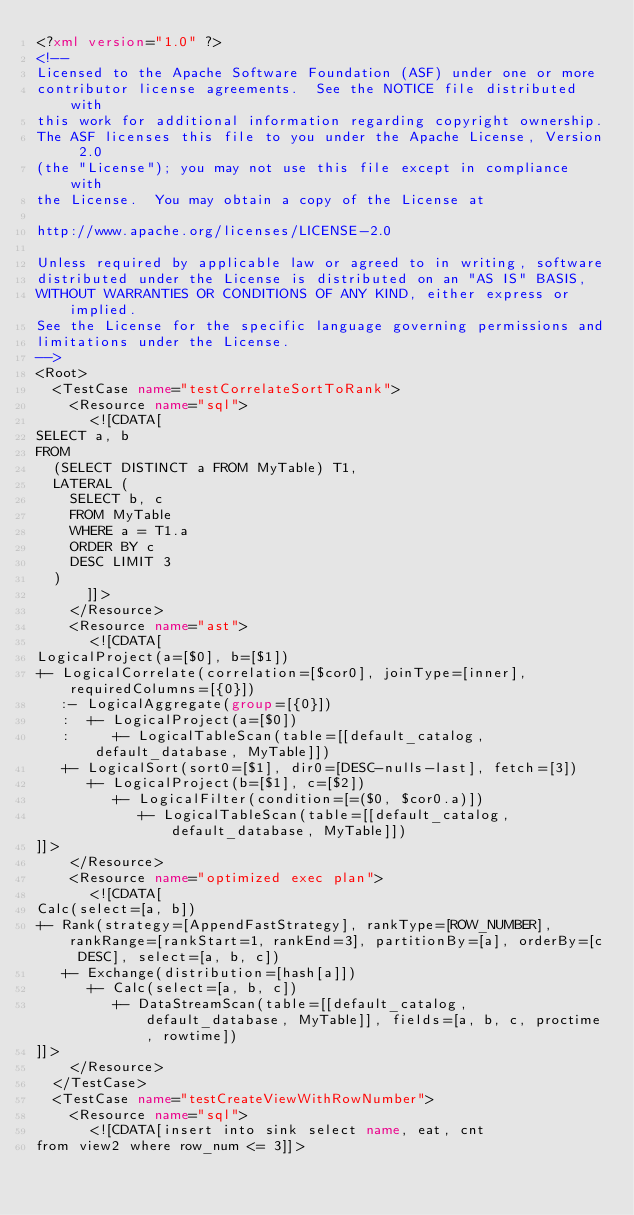Convert code to text. <code><loc_0><loc_0><loc_500><loc_500><_XML_><?xml version="1.0" ?>
<!--
Licensed to the Apache Software Foundation (ASF) under one or more
contributor license agreements.  See the NOTICE file distributed with
this work for additional information regarding copyright ownership.
The ASF licenses this file to you under the Apache License, Version 2.0
(the "License"); you may not use this file except in compliance with
the License.  You may obtain a copy of the License at

http://www.apache.org/licenses/LICENSE-2.0

Unless required by applicable law or agreed to in writing, software
distributed under the License is distributed on an "AS IS" BASIS,
WITHOUT WARRANTIES OR CONDITIONS OF ANY KIND, either express or implied.
See the License for the specific language governing permissions and
limitations under the License.
-->
<Root>
  <TestCase name="testCorrelateSortToRank">
    <Resource name="sql">
      <![CDATA[
SELECT a, b
FROM
  (SELECT DISTINCT a FROM MyTable) T1,
  LATERAL (
    SELECT b, c
    FROM MyTable
    WHERE a = T1.a
    ORDER BY c
    DESC LIMIT 3
  )
      ]]>
    </Resource>
    <Resource name="ast">
      <![CDATA[
LogicalProject(a=[$0], b=[$1])
+- LogicalCorrelate(correlation=[$cor0], joinType=[inner], requiredColumns=[{0}])
   :- LogicalAggregate(group=[{0}])
   :  +- LogicalProject(a=[$0])
   :     +- LogicalTableScan(table=[[default_catalog, default_database, MyTable]])
   +- LogicalSort(sort0=[$1], dir0=[DESC-nulls-last], fetch=[3])
      +- LogicalProject(b=[$1], c=[$2])
         +- LogicalFilter(condition=[=($0, $cor0.a)])
            +- LogicalTableScan(table=[[default_catalog, default_database, MyTable]])
]]>
    </Resource>
    <Resource name="optimized exec plan">
      <![CDATA[
Calc(select=[a, b])
+- Rank(strategy=[AppendFastStrategy], rankType=[ROW_NUMBER], rankRange=[rankStart=1, rankEnd=3], partitionBy=[a], orderBy=[c DESC], select=[a, b, c])
   +- Exchange(distribution=[hash[a]])
      +- Calc(select=[a, b, c])
         +- DataStreamScan(table=[[default_catalog, default_database, MyTable]], fields=[a, b, c, proctime, rowtime])
]]>
    </Resource>
  </TestCase>
  <TestCase name="testCreateViewWithRowNumber">
    <Resource name="sql">
      <![CDATA[insert into sink select name, eat, cnt
from view2 where row_num <= 3]]></code> 